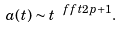<formula> <loc_0><loc_0><loc_500><loc_500>a ( t ) \sim t ^ { \ f f t { 2 } { p + 1 } } .</formula> 